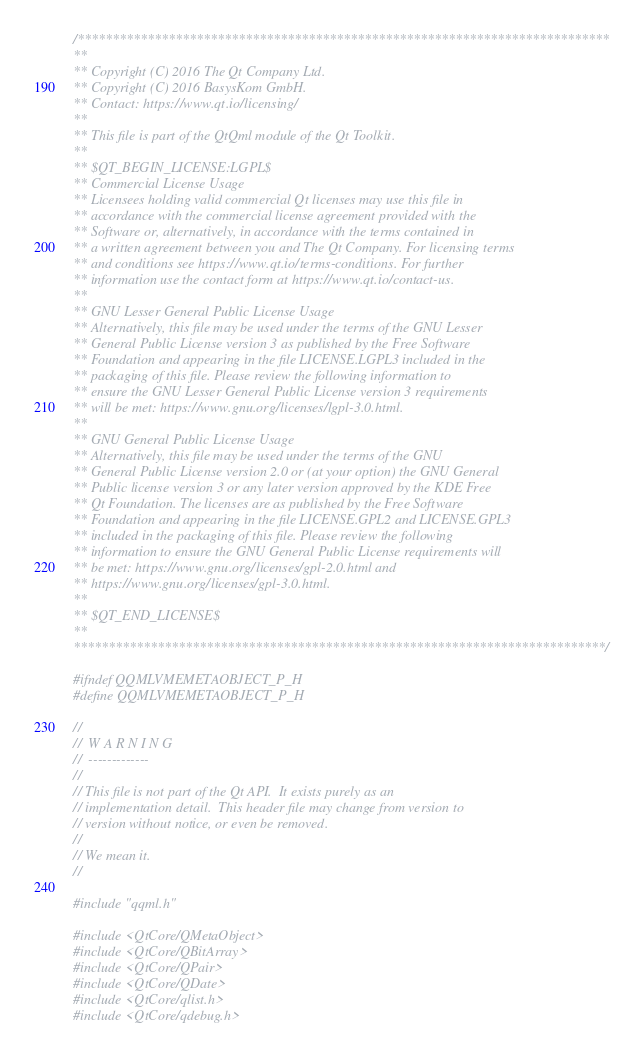Convert code to text. <code><loc_0><loc_0><loc_500><loc_500><_C_>/****************************************************************************
**
** Copyright (C) 2016 The Qt Company Ltd.
** Copyright (C) 2016 BasysKom GmbH.
** Contact: https://www.qt.io/licensing/
**
** This file is part of the QtQml module of the Qt Toolkit.
**
** $QT_BEGIN_LICENSE:LGPL$
** Commercial License Usage
** Licensees holding valid commercial Qt licenses may use this file in
** accordance with the commercial license agreement provided with the
** Software or, alternatively, in accordance with the terms contained in
** a written agreement between you and The Qt Company. For licensing terms
** and conditions see https://www.qt.io/terms-conditions. For further
** information use the contact form at https://www.qt.io/contact-us.
**
** GNU Lesser General Public License Usage
** Alternatively, this file may be used under the terms of the GNU Lesser
** General Public License version 3 as published by the Free Software
** Foundation and appearing in the file LICENSE.LGPL3 included in the
** packaging of this file. Please review the following information to
** ensure the GNU Lesser General Public License version 3 requirements
** will be met: https://www.gnu.org/licenses/lgpl-3.0.html.
**
** GNU General Public License Usage
** Alternatively, this file may be used under the terms of the GNU
** General Public License version 2.0 or (at your option) the GNU General
** Public license version 3 or any later version approved by the KDE Free
** Qt Foundation. The licenses are as published by the Free Software
** Foundation and appearing in the file LICENSE.GPL2 and LICENSE.GPL3
** included in the packaging of this file. Please review the following
** information to ensure the GNU General Public License requirements will
** be met: https://www.gnu.org/licenses/gpl-2.0.html and
** https://www.gnu.org/licenses/gpl-3.0.html.
**
** $QT_END_LICENSE$
**
****************************************************************************/

#ifndef QQMLVMEMETAOBJECT_P_H
#define QQMLVMEMETAOBJECT_P_H

//
//  W A R N I N G
//  -------------
//
// This file is not part of the Qt API.  It exists purely as an
// implementation detail.  This header file may change from version to
// version without notice, or even be removed.
//
// We mean it.
//

#include "qqml.h"

#include <QtCore/QMetaObject>
#include <QtCore/QBitArray>
#include <QtCore/QPair>
#include <QtCore/QDate>
#include <QtCore/qlist.h>
#include <QtCore/qdebug.h>
</code> 